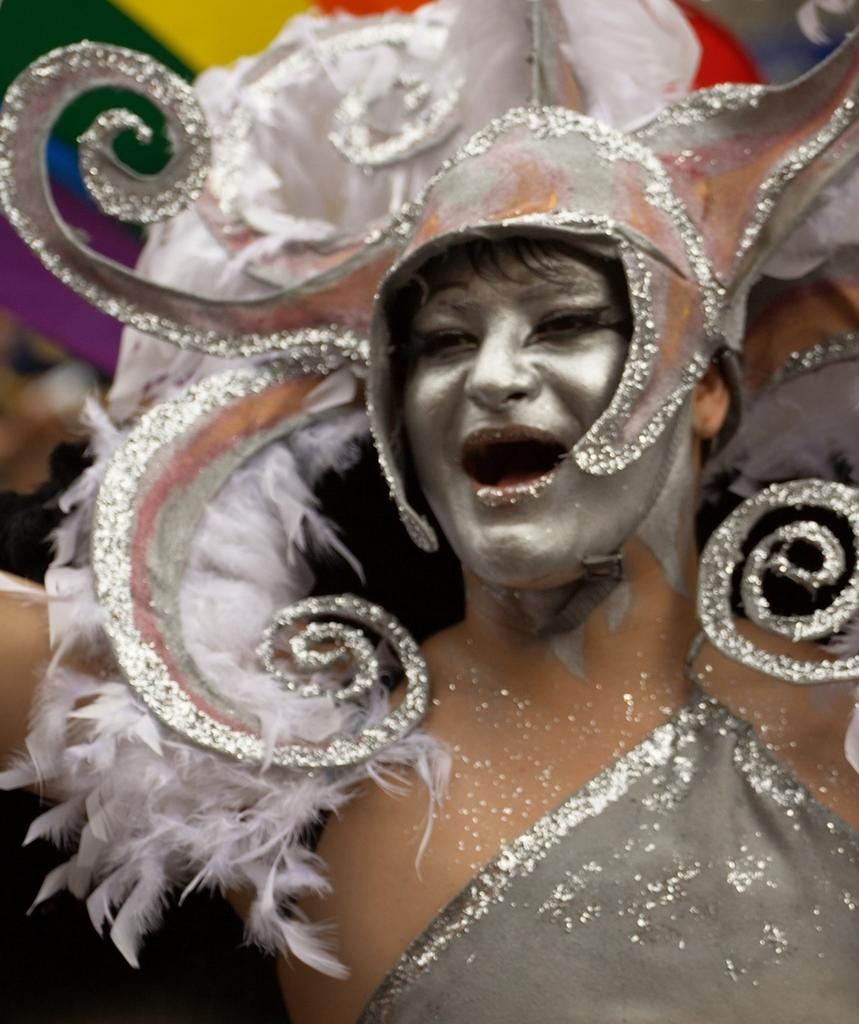What is the main subject of the image? There is a person in the middle of the image. Can you describe the person's appearance? The person is wearing a grey costume and has paint on their face. How would you describe the background of the image? The background of the image is blurred. How many pies did the person attempt to bake this week in the image? There is no mention of pies or baking in the image, so it cannot be determined from the image. 